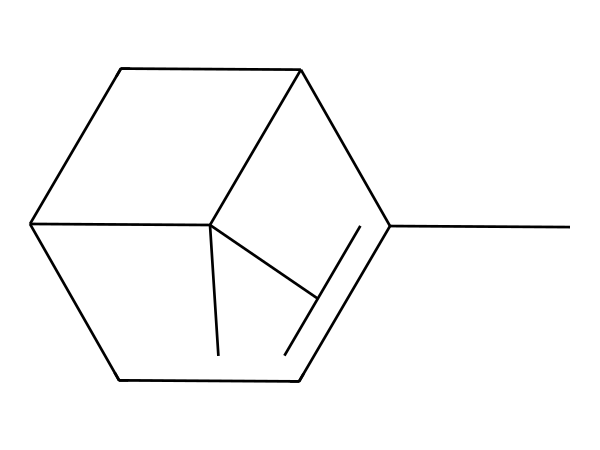What is the molecular formula of alpha-pinene? To determine the molecular formula, we count the number of each type of atom in the SMILES representation. The structure indicates there are 10 carbon atoms, 16 hydrogen atoms, and no heteroatoms. Thus, the molecular formula is C10H16.
Answer: C10H16 How many rings are present in the structure of alpha-pinene? By examining the SMILES representation, we notice that it has two cyclical components (indicated by the numbers in the structure). Therefore, there are two rings in alpha-pinene.
Answer: 2 What is the total number of hydrogen atoms attached to alpha-pinene? Looking at the molecular formula established from the previous analysis, we see it contains 16 hydrogen atoms total.
Answer: 16 What type of compound is alpha-pinene classified as? Alpha-pinene is a naturally occurring organic compound classified as a terpene, which is characterized by its structure and occurrence in essential oils.
Answer: terpene Why is alpha-pinene commonly used in aromatherapy? Alpha-pinene is known for its fresh, pine-like scent which is often associated with stimulating and invigorating characteristics, making it popular in aromatherapy for relaxation and mental clarity.
Answer: stimulating What is the general reactivity of terpenes like alpha-pinene? Terpenes, including alpha-pinene, are generally reactive compounds, especially in terms of their ability to participate in reactions such as oxidation due to their unsaturated structures (double bonds).
Answer: reactive 